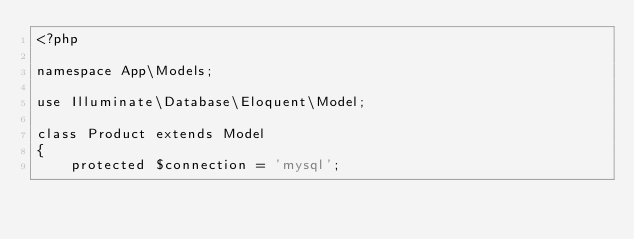<code> <loc_0><loc_0><loc_500><loc_500><_PHP_><?php

namespace App\Models;

use Illuminate\Database\Eloquent\Model;

class Product extends Model
{
    protected $connection = 'mysql';</code> 